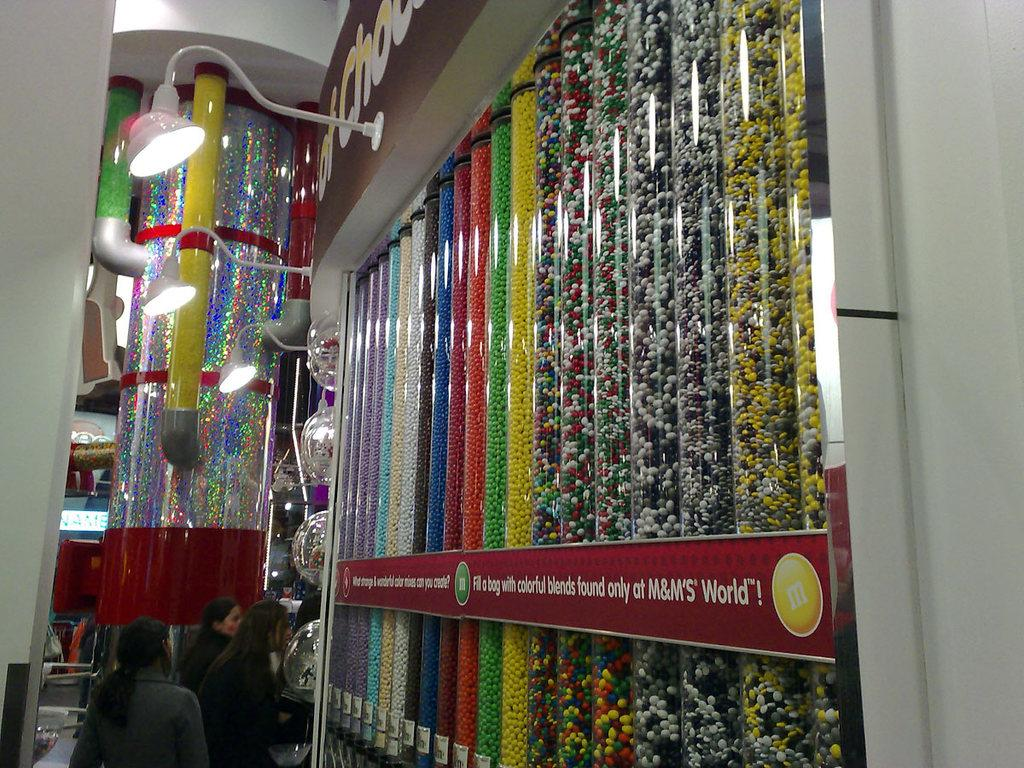Provide a one-sentence caption for the provided image. M logo for the candy m & m and a banner that says fill a bag with colorful blends found only at M&M. 